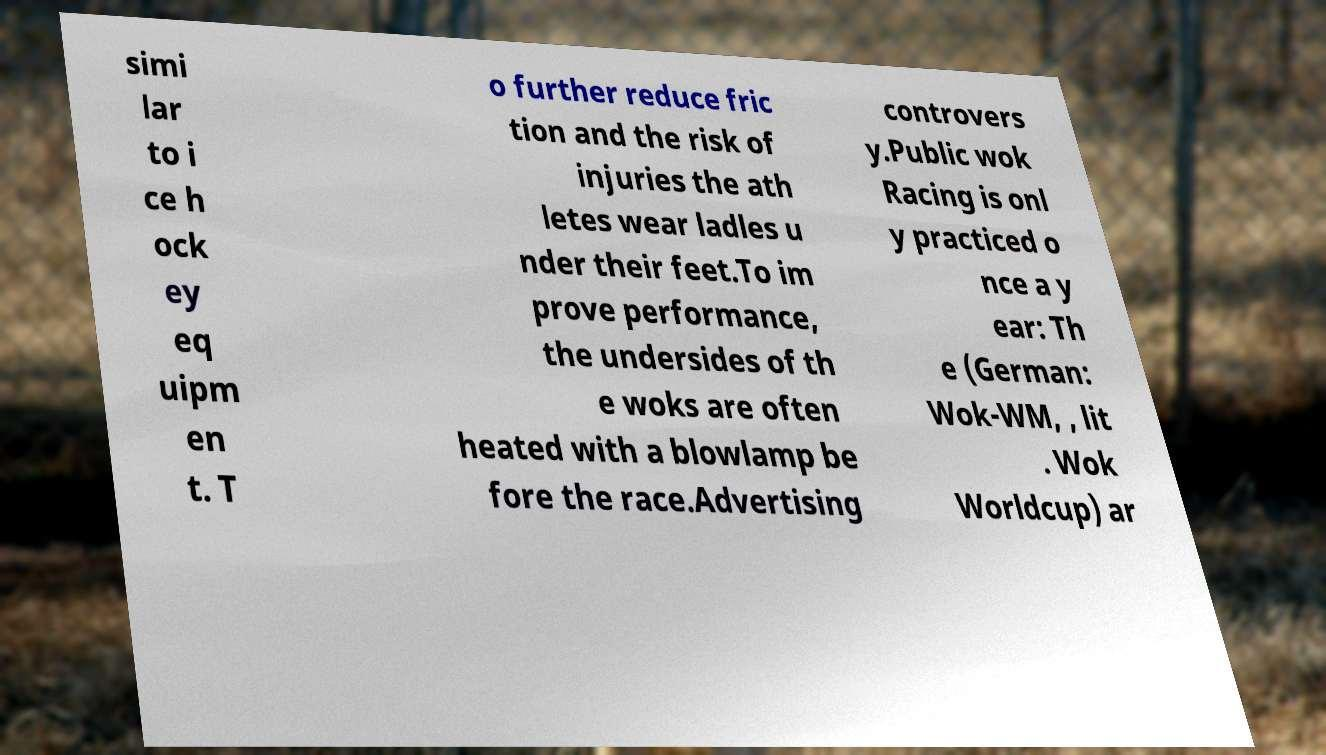Please identify and transcribe the text found in this image. simi lar to i ce h ock ey eq uipm en t. T o further reduce fric tion and the risk of injuries the ath letes wear ladles u nder their feet.To im prove performance, the undersides of th e woks are often heated with a blowlamp be fore the race.Advertising controvers y.Public wok Racing is onl y practiced o nce a y ear: Th e (German: Wok-WM, , lit . Wok Worldcup) ar 